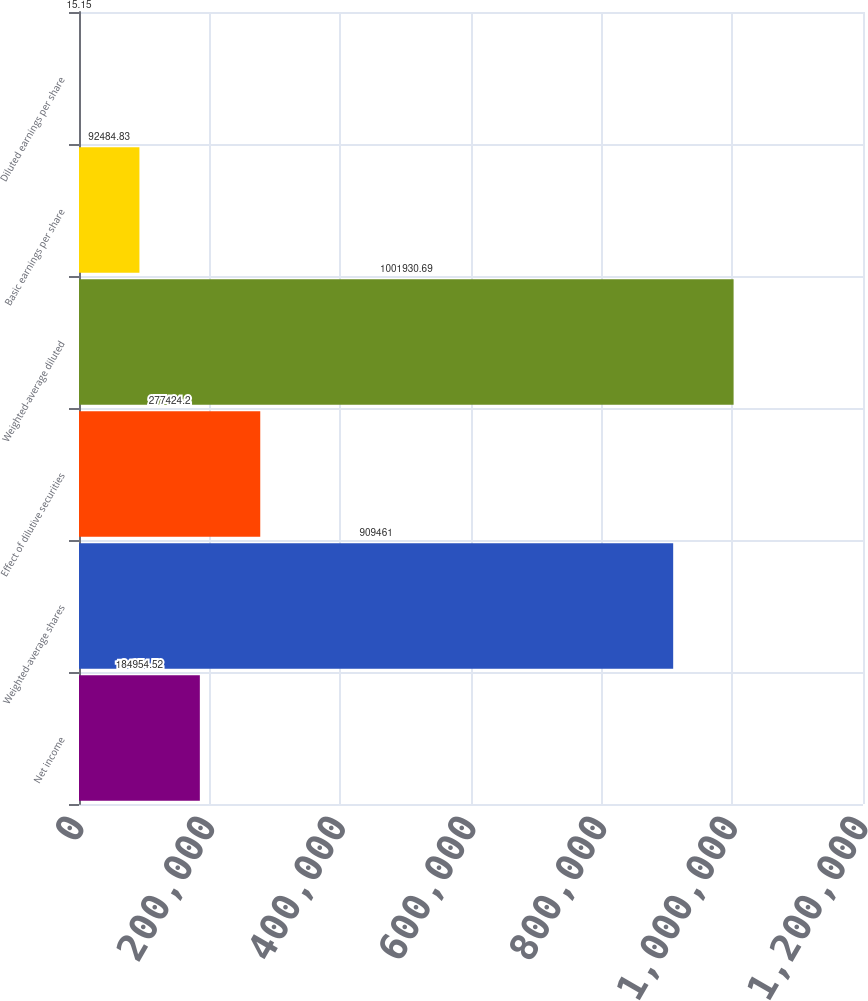Convert chart. <chart><loc_0><loc_0><loc_500><loc_500><bar_chart><fcel>Net income<fcel>Weighted-average shares<fcel>Effect of dilutive securities<fcel>Weighted-average diluted<fcel>Basic earnings per share<fcel>Diluted earnings per share<nl><fcel>184955<fcel>909461<fcel>277424<fcel>1.00193e+06<fcel>92484.8<fcel>15.15<nl></chart> 